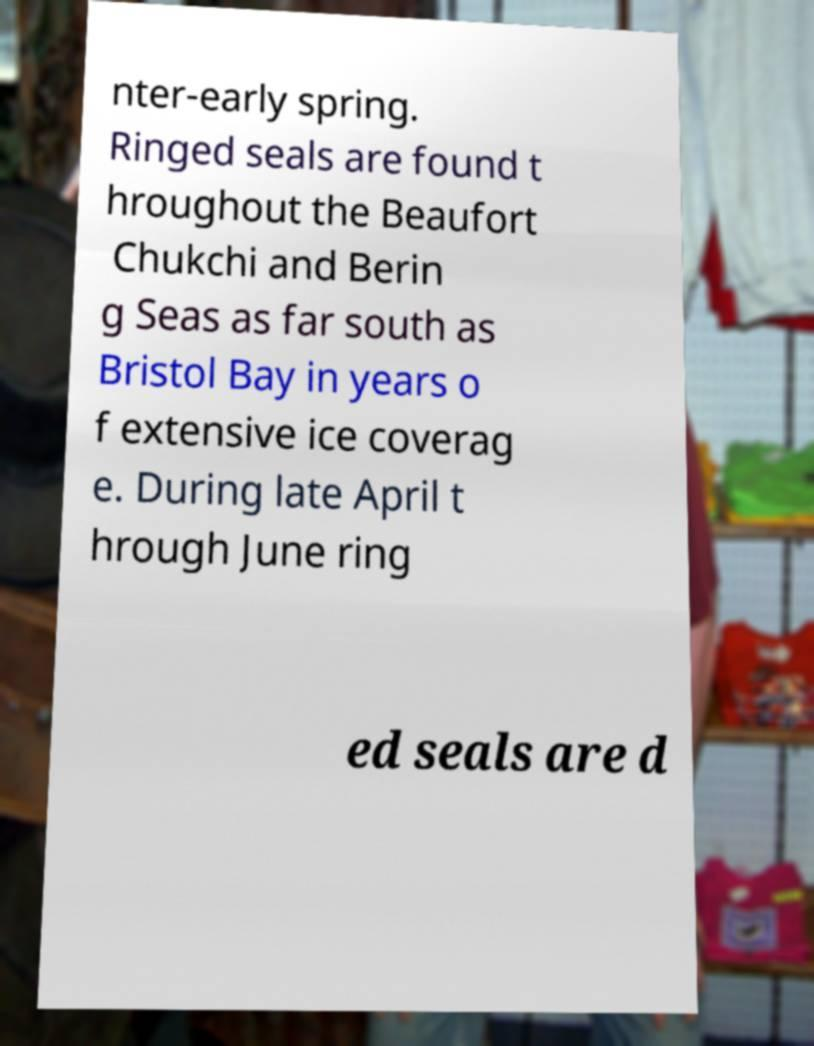Can you read and provide the text displayed in the image?This photo seems to have some interesting text. Can you extract and type it out for me? nter-early spring. Ringed seals are found t hroughout the Beaufort Chukchi and Berin g Seas as far south as Bristol Bay in years o f extensive ice coverag e. During late April t hrough June ring ed seals are d 